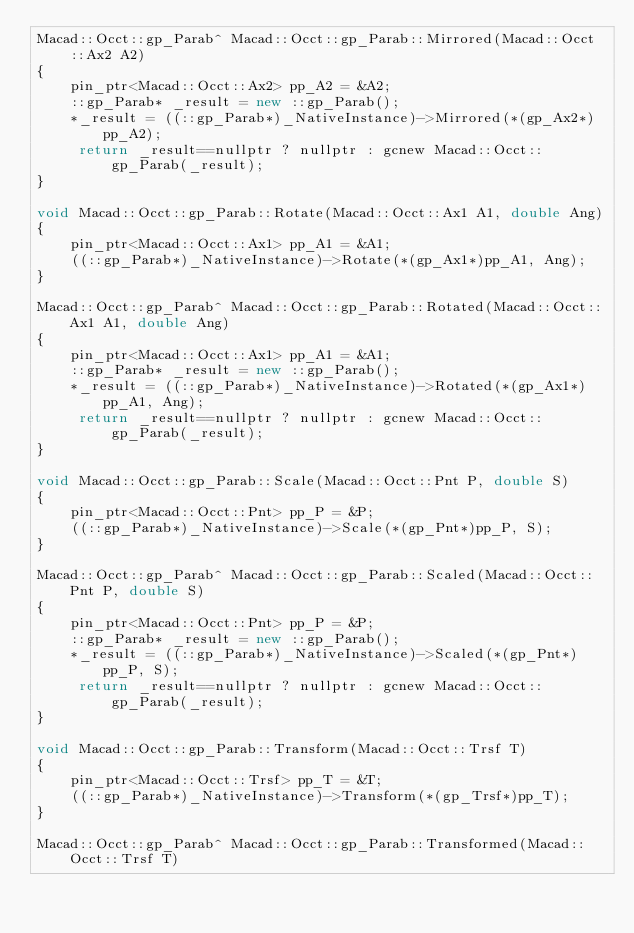Convert code to text. <code><loc_0><loc_0><loc_500><loc_500><_C++_>Macad::Occt::gp_Parab^ Macad::Occt::gp_Parab::Mirrored(Macad::Occt::Ax2 A2)
{
	pin_ptr<Macad::Occt::Ax2> pp_A2 = &A2;
	::gp_Parab* _result = new ::gp_Parab();
	*_result = ((::gp_Parab*)_NativeInstance)->Mirrored(*(gp_Ax2*)pp_A2);
	 return _result==nullptr ? nullptr : gcnew Macad::Occt::gp_Parab(_result);
}

void Macad::Occt::gp_Parab::Rotate(Macad::Occt::Ax1 A1, double Ang)
{
	pin_ptr<Macad::Occt::Ax1> pp_A1 = &A1;
	((::gp_Parab*)_NativeInstance)->Rotate(*(gp_Ax1*)pp_A1, Ang);
}

Macad::Occt::gp_Parab^ Macad::Occt::gp_Parab::Rotated(Macad::Occt::Ax1 A1, double Ang)
{
	pin_ptr<Macad::Occt::Ax1> pp_A1 = &A1;
	::gp_Parab* _result = new ::gp_Parab();
	*_result = ((::gp_Parab*)_NativeInstance)->Rotated(*(gp_Ax1*)pp_A1, Ang);
	 return _result==nullptr ? nullptr : gcnew Macad::Occt::gp_Parab(_result);
}

void Macad::Occt::gp_Parab::Scale(Macad::Occt::Pnt P, double S)
{
	pin_ptr<Macad::Occt::Pnt> pp_P = &P;
	((::gp_Parab*)_NativeInstance)->Scale(*(gp_Pnt*)pp_P, S);
}

Macad::Occt::gp_Parab^ Macad::Occt::gp_Parab::Scaled(Macad::Occt::Pnt P, double S)
{
	pin_ptr<Macad::Occt::Pnt> pp_P = &P;
	::gp_Parab* _result = new ::gp_Parab();
	*_result = ((::gp_Parab*)_NativeInstance)->Scaled(*(gp_Pnt*)pp_P, S);
	 return _result==nullptr ? nullptr : gcnew Macad::Occt::gp_Parab(_result);
}

void Macad::Occt::gp_Parab::Transform(Macad::Occt::Trsf T)
{
	pin_ptr<Macad::Occt::Trsf> pp_T = &T;
	((::gp_Parab*)_NativeInstance)->Transform(*(gp_Trsf*)pp_T);
}

Macad::Occt::gp_Parab^ Macad::Occt::gp_Parab::Transformed(Macad::Occt::Trsf T)</code> 